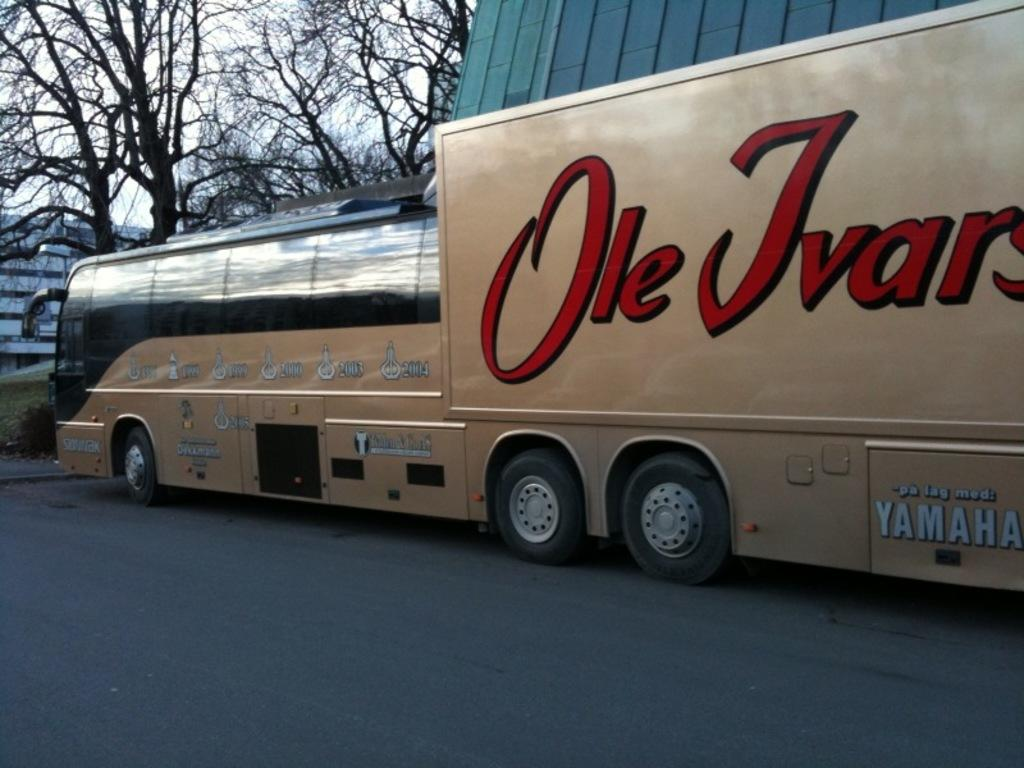What is the main subject of the image? There is a vehicle on the road in the image. What can be seen in the background of the image? There is a building and branches visible in the background of the image. What part of the natural environment is visible in the image? The sky is visible in the background of the image. Where can the toothpaste be found in the image? There is no toothpaste present in the image. What type of sticks are being used by the vehicle in the image? There are no sticks being used by the vehicle in the image. 